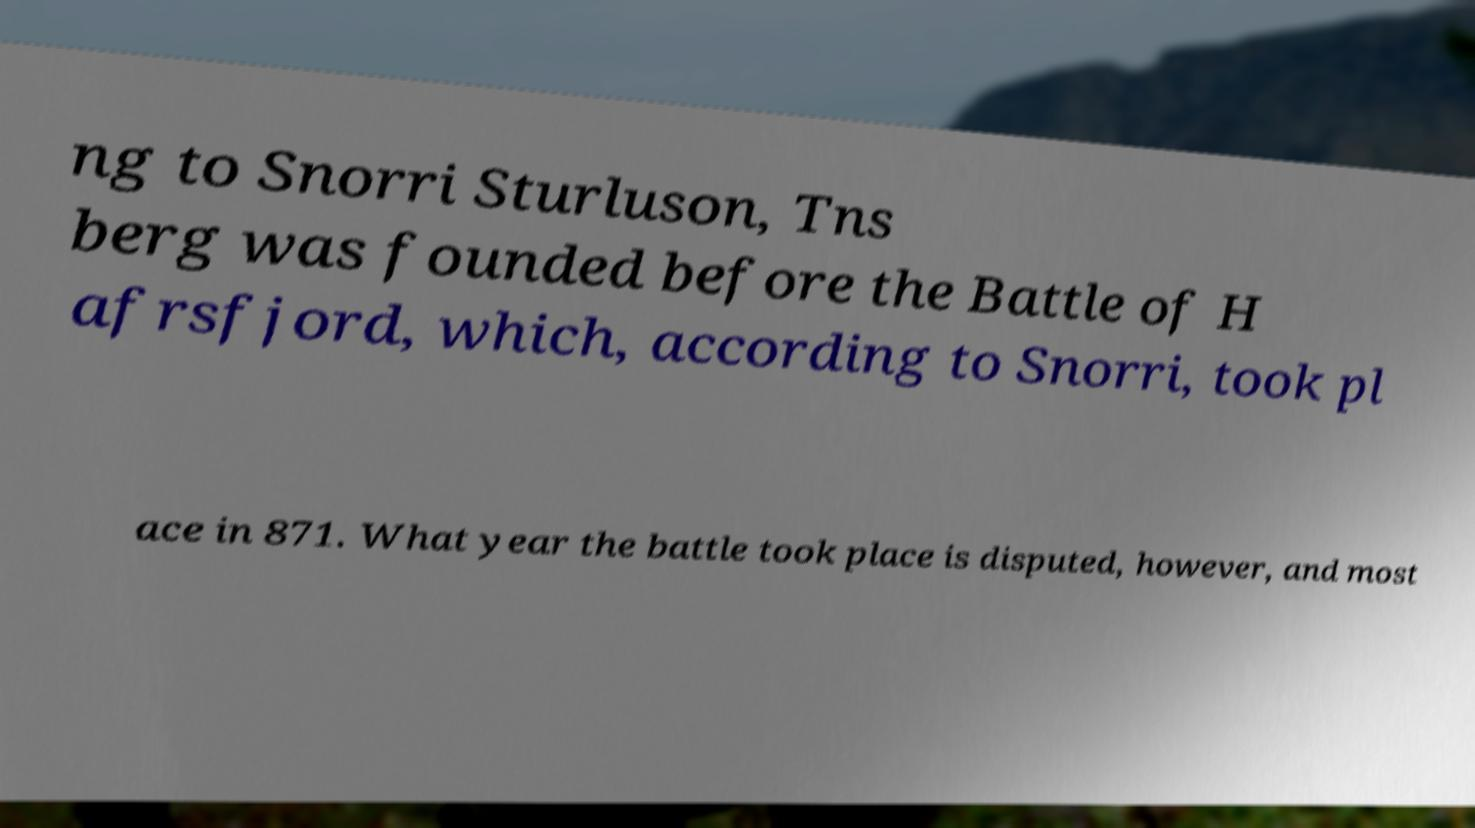Can you read and provide the text displayed in the image?This photo seems to have some interesting text. Can you extract and type it out for me? ng to Snorri Sturluson, Tns berg was founded before the Battle of H afrsfjord, which, according to Snorri, took pl ace in 871. What year the battle took place is disputed, however, and most 